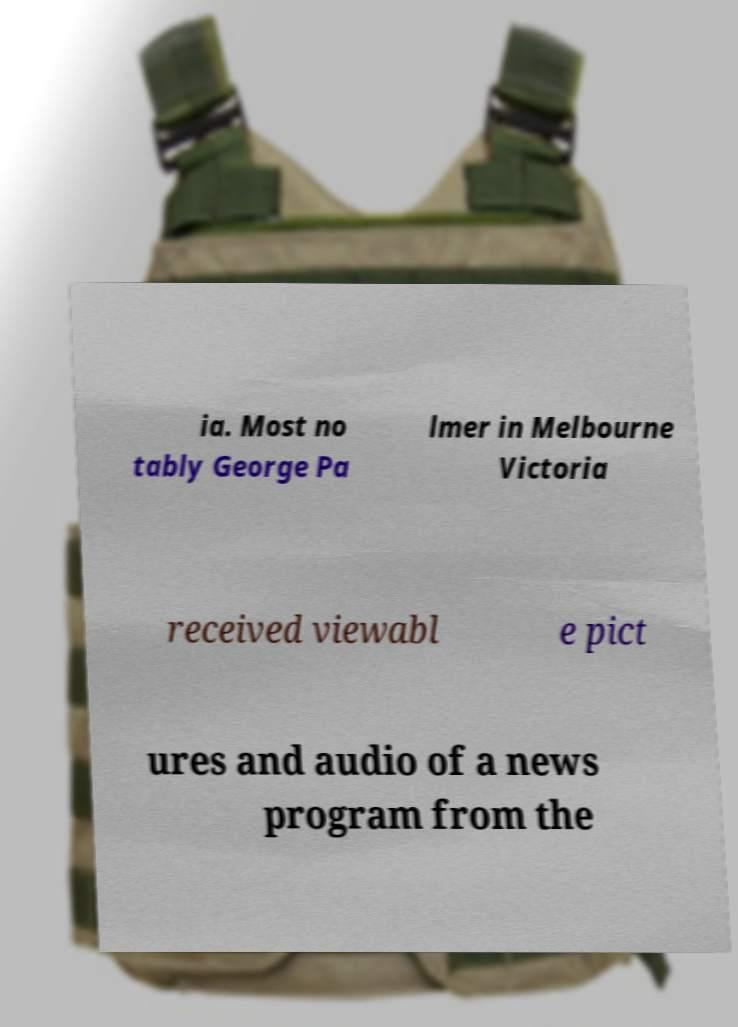I need the written content from this picture converted into text. Can you do that? ia. Most no tably George Pa lmer in Melbourne Victoria received viewabl e pict ures and audio of a news program from the 